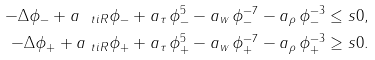Convert formula to latex. <formula><loc_0><loc_0><loc_500><loc_500>- \Delta \phi _ { - } + a _ { \ t i R } \phi _ { - } + a _ { \tau } \, \phi _ { - } ^ { 5 } - a _ { w } \, \phi _ { - } ^ { - 7 } - a _ { \rho } \, \phi _ { - } ^ { - 3 } & \leq s 0 , \\ - \Delta \phi _ { + } + a _ { \ t i R } \phi _ { + } + a _ { \tau } \, \phi _ { + } ^ { 5 } - a _ { w } \, \phi _ { + } ^ { - 7 } - a _ { \rho } \, \phi _ { + } ^ { - 3 } & \geq s 0 .</formula> 